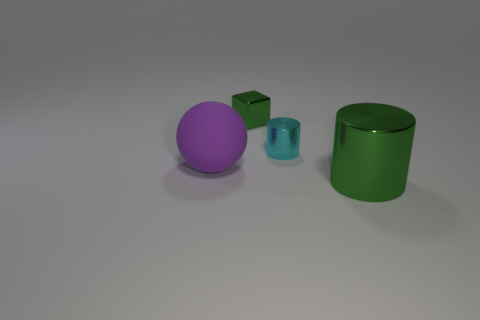There is a large cylinder that is the same color as the shiny cube; what is it made of?
Your response must be concise. Metal. The object that is in front of the cyan cylinder and right of the green metallic block is what color?
Your answer should be very brief. Green. The small thing that is on the left side of the small thing that is to the right of the green cube is made of what material?
Keep it short and to the point. Metal. Do the purple rubber sphere and the green shiny cylinder have the same size?
Offer a terse response. Yes. How many small things are either rubber balls or red rubber things?
Provide a short and direct response. 0. What number of tiny objects are behind the green cylinder?
Your answer should be compact. 2. Is the number of small shiny cylinders in front of the small green metallic block greater than the number of large purple metallic balls?
Offer a terse response. Yes. What shape is the other green object that is the same material as the big green thing?
Provide a succinct answer. Cube. There is a metal cylinder that is behind the green shiny object in front of the big purple sphere; what color is it?
Provide a short and direct response. Cyan. Is the big green shiny object the same shape as the tiny cyan thing?
Keep it short and to the point. Yes. 